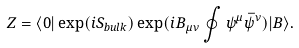<formula> <loc_0><loc_0><loc_500><loc_500>Z = \langle 0 | \exp ( i S _ { b u l k } ) \exp ( i B _ { \mu \nu } \oint \psi ^ { \mu } \bar { \psi } ^ { \nu } ) | B \rangle .</formula> 